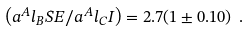<formula> <loc_0><loc_0><loc_500><loc_500>\left ( a ^ { A } l _ { B } S E / a ^ { A } l _ { C } I \right ) = 2 . 7 ( 1 \pm 0 . 1 0 ) \ .</formula> 